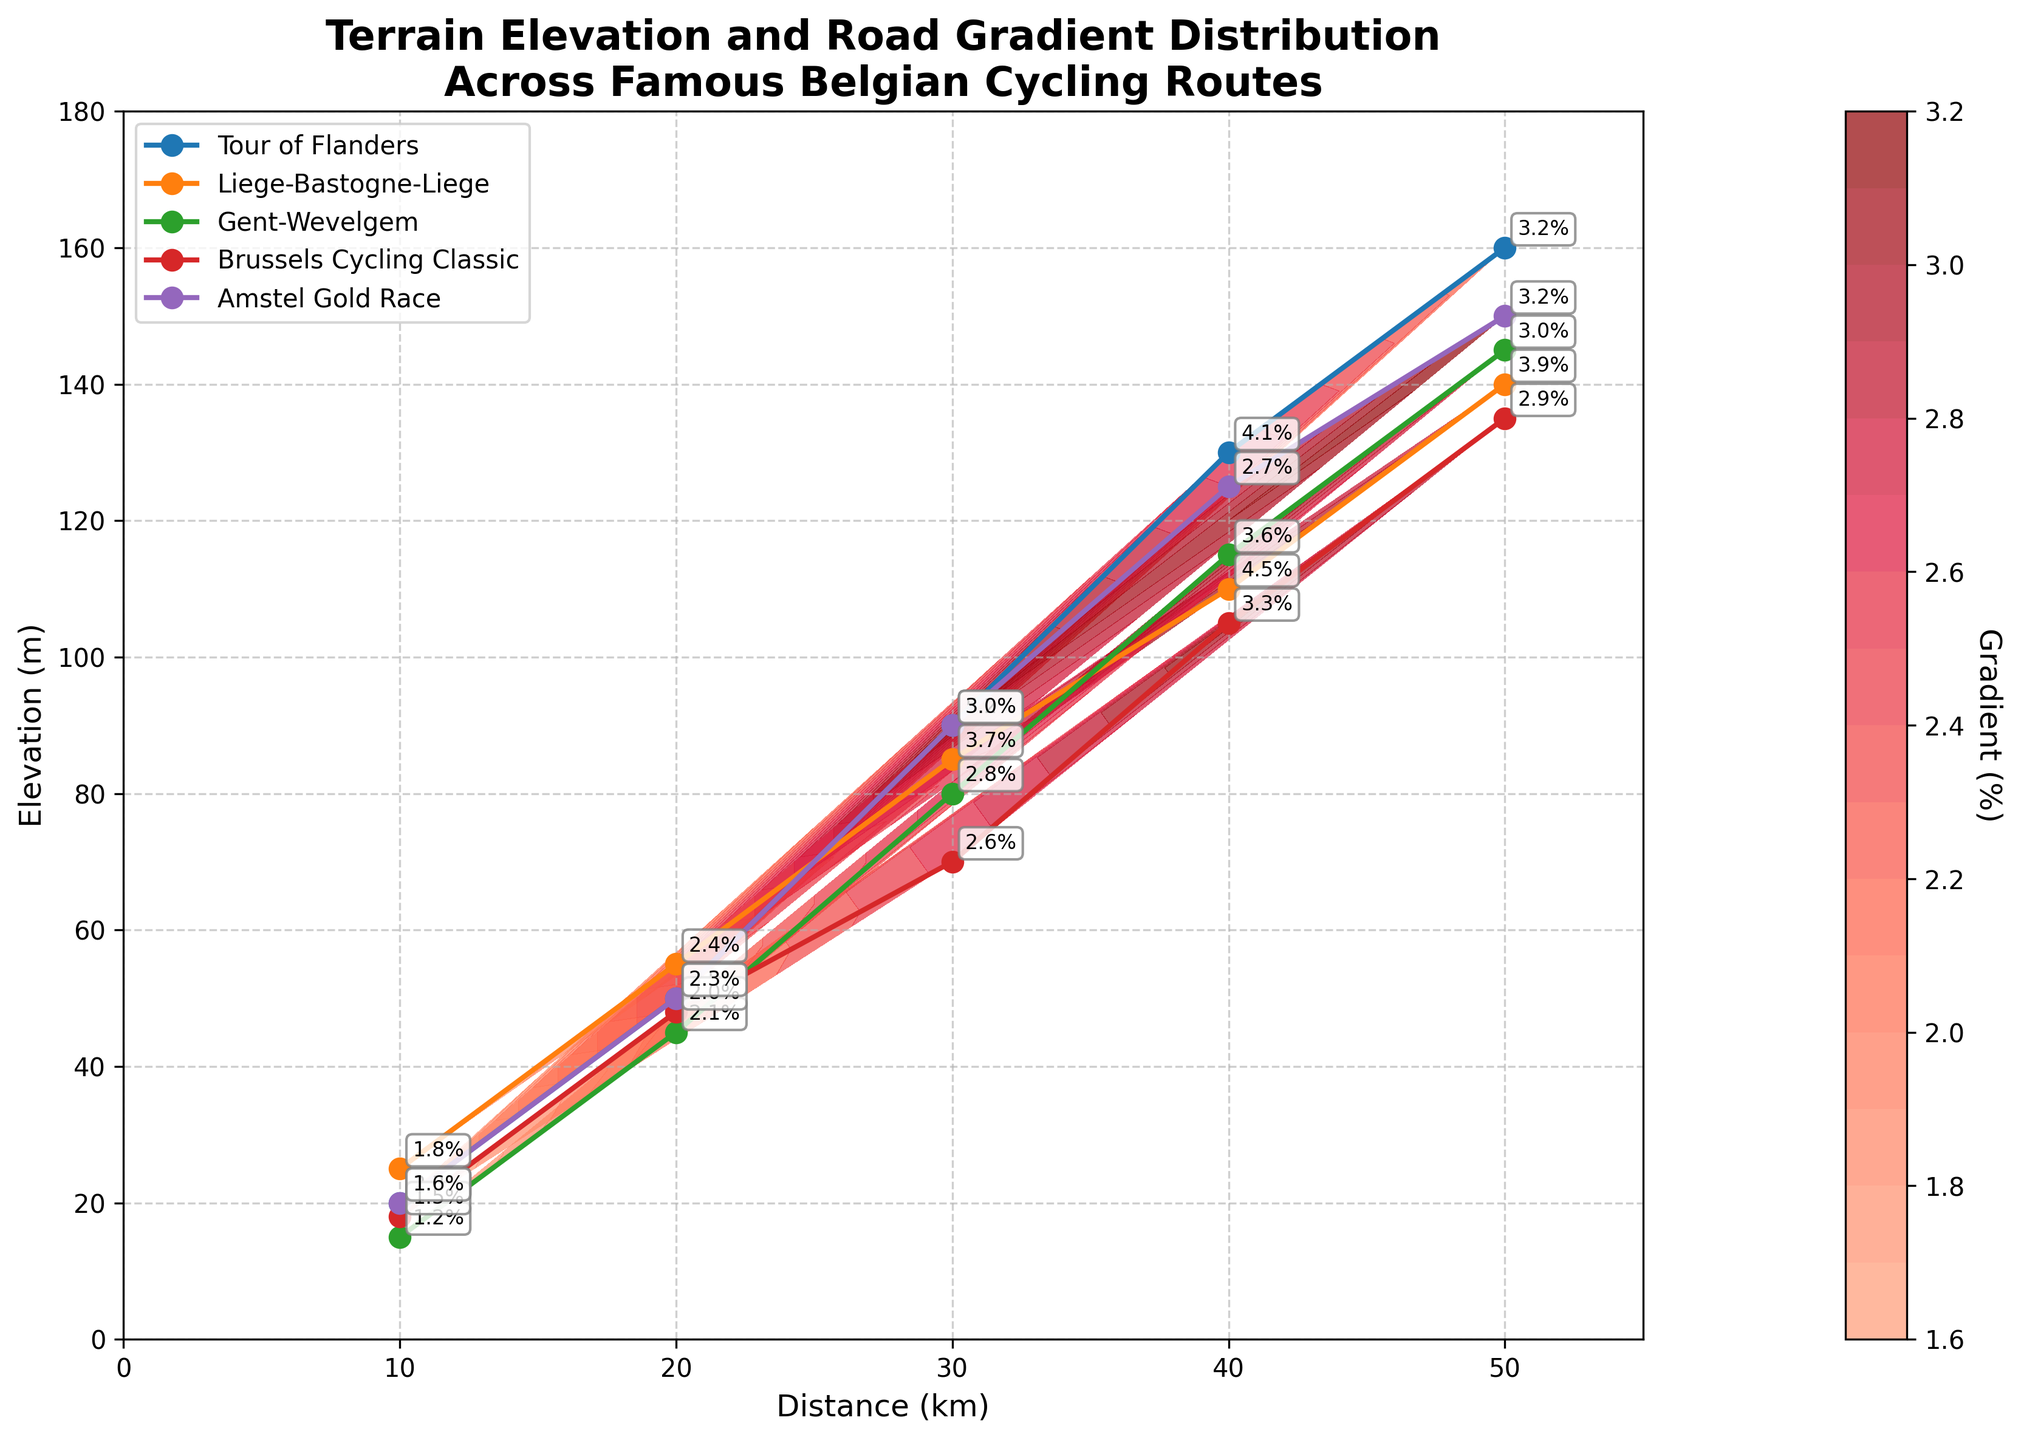What is the title of the plot? The title of the plot is displayed at the top of the figure, and it mentions the terrain elevation and road gradient distribution.
Answer: Terrain Elevation and Road Gradient Distribution Across Famous Belgian Cycling Routes What is the maximum elevation shown in the plot? The maximum elevation can be identified by looking at the y-axis and seeing the highest point reached by the data points.
Answer: 160 meters Which route has the steepest gradient at the 30 km distance? To determine the steepest gradient at 30 km, look for the labels on the plot corresponding to 30 km and compare their gradient percentages.
Answer: Tour of Flanders Between the Brussels Cycling Classic and the Gent-Wevelgem routes, which one has a higher elevation at 40 km? Compare the y-values of the Brussels Cycling Classic and the Gent-Wevelgem at the 40 km mark on the x-axis.
Answer: Gent-Wevelgem What is the elevation difference between the 10 km and 50 km marks on the Amstel Gold Race route? Subtract the elevation at 10 km from the elevation at 50 km by locating these points on the plot.
Answer: 130 meters Which route has the lowest gradient at any given distance? Look for the lowest gradient percentage label on the entire plot and identify the corresponding route.
Answer: Gent-Wevelgem How does the gradient change as the distance increases on the Liege-Bastogne-Liege route? By following the contour labels along the Liege-Bastogne-Liege route from 10 km to 50 km, we can see how the gradient percentage changes.
Answer: It generally increases and then slightly decreases What is the average gradient percentage at the 50 km mark across all routes? Add the gradient percentages at the 50 km mark for all routes and divide by the number of routes.
Answer: 3.24% Which route has the highest elevation gain from the start to the finish (10 km to 50 km)? Calculate the elevation difference from 10 km to 50 km for each route and compare the differences.
Answer: Tour of Flanders 